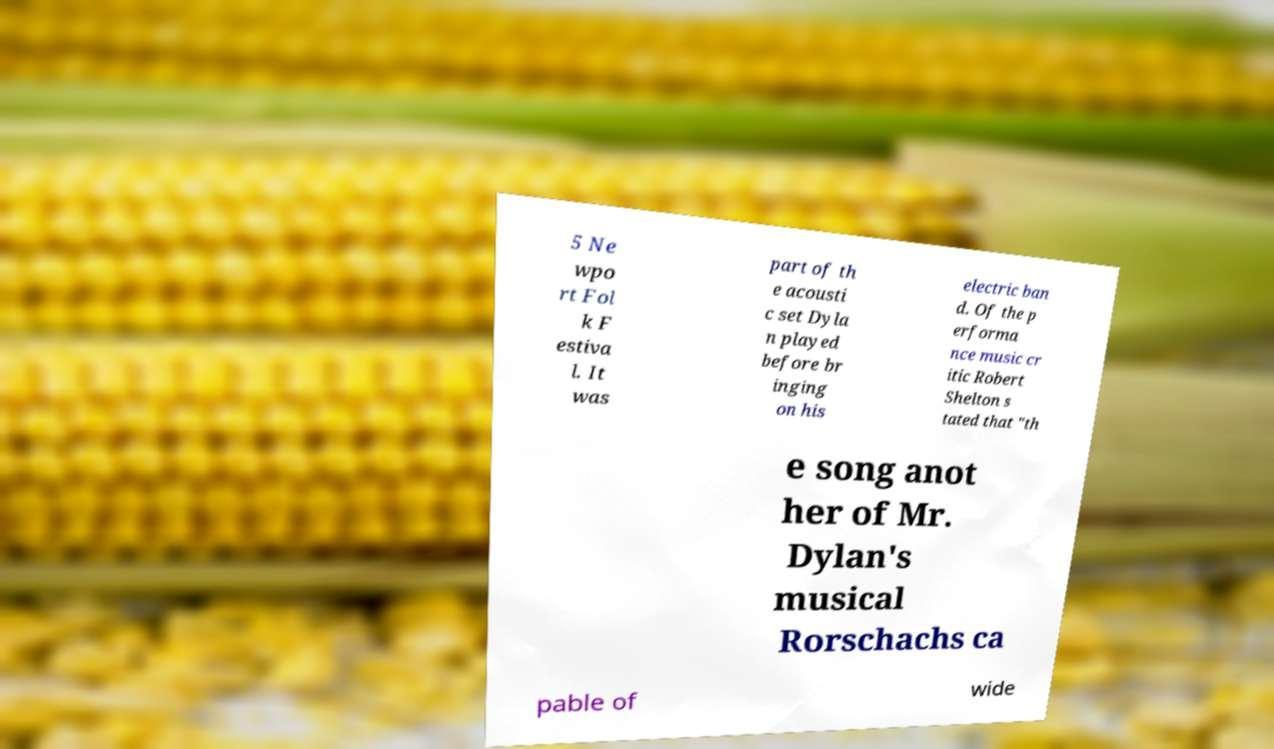Could you extract and type out the text from this image? 5 Ne wpo rt Fol k F estiva l. It was part of th e acousti c set Dyla n played before br inging on his electric ban d. Of the p erforma nce music cr itic Robert Shelton s tated that "th e song anot her of Mr. Dylan's musical Rorschachs ca pable of wide 